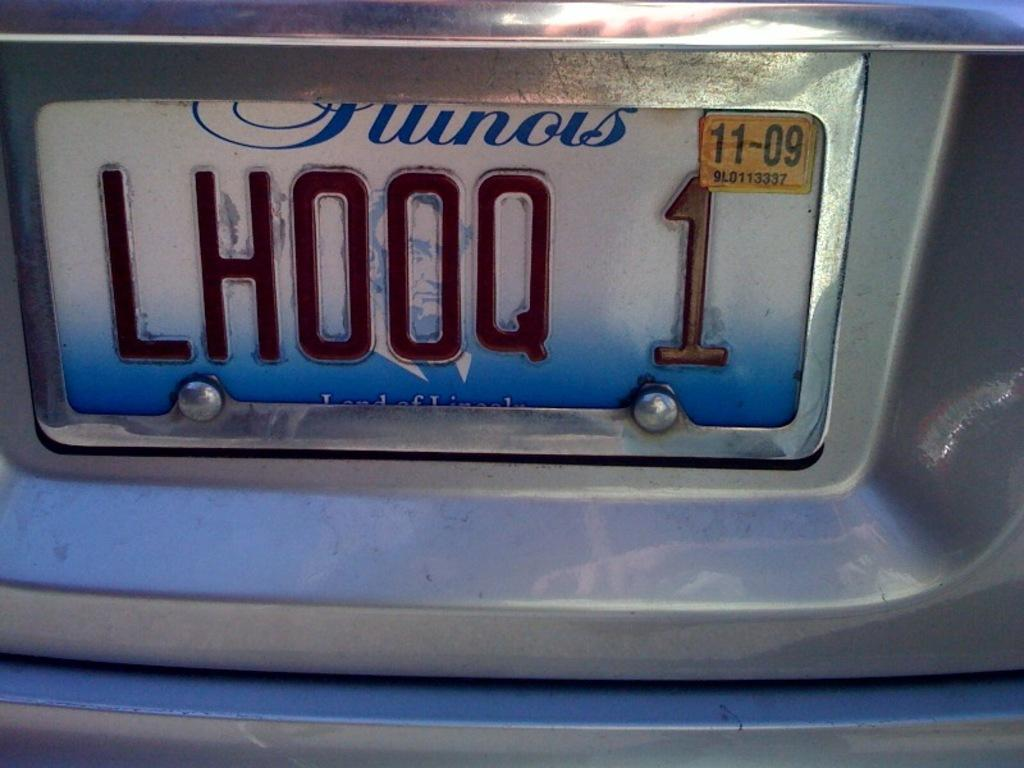<image>
Provide a brief description of the given image. An Illinois license plate number that expires on 11/09 is LHOOQ 1. 